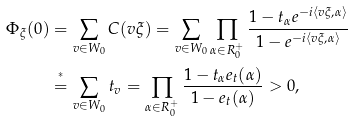<formula> <loc_0><loc_0><loc_500><loc_500>\Phi _ { \xi } ( 0 ) & = \sum _ { v \in W _ { 0 } } C ( v \xi ) = \sum _ { v \in W _ { 0 } } \prod _ { \alpha \in R ^ { + } _ { 0 } } \frac { 1 - t _ { \alpha } e ^ { - i \langle v \xi , \alpha \rangle } } { 1 - e ^ { - i \langle v \xi , \alpha \rangle } } \\ & \stackrel { ^ { * } } { = } \sum _ { v \in W _ { 0 } } t _ { v } = \prod _ { \alpha \in R _ { 0 } ^ { + } } \frac { 1 - t _ { \alpha } e _ { t } ( \alpha ) } { 1 - e _ { t } ( \alpha ) } > 0 ,</formula> 